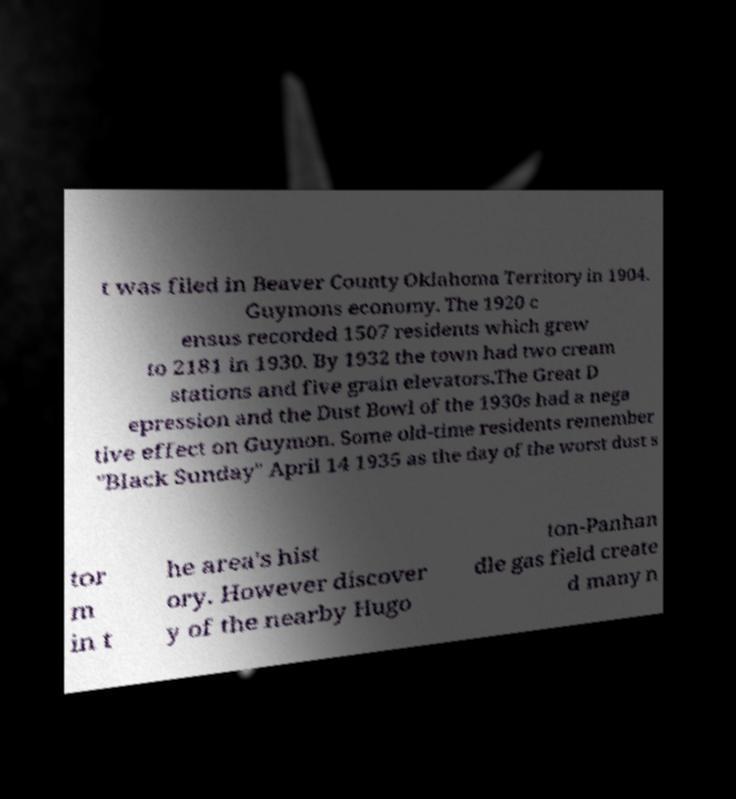Please identify and transcribe the text found in this image. t was filed in Beaver County Oklahoma Territory in 1904. Guymons economy. The 1920 c ensus recorded 1507 residents which grew to 2181 in 1930. By 1932 the town had two cream stations and five grain elevators.The Great D epression and the Dust Bowl of the 1930s had a nega tive effect on Guymon. Some old-time residents remember "Black Sunday" April 14 1935 as the day of the worst dust s tor m in t he area's hist ory. However discover y of the nearby Hugo ton-Panhan dle gas field create d many n 